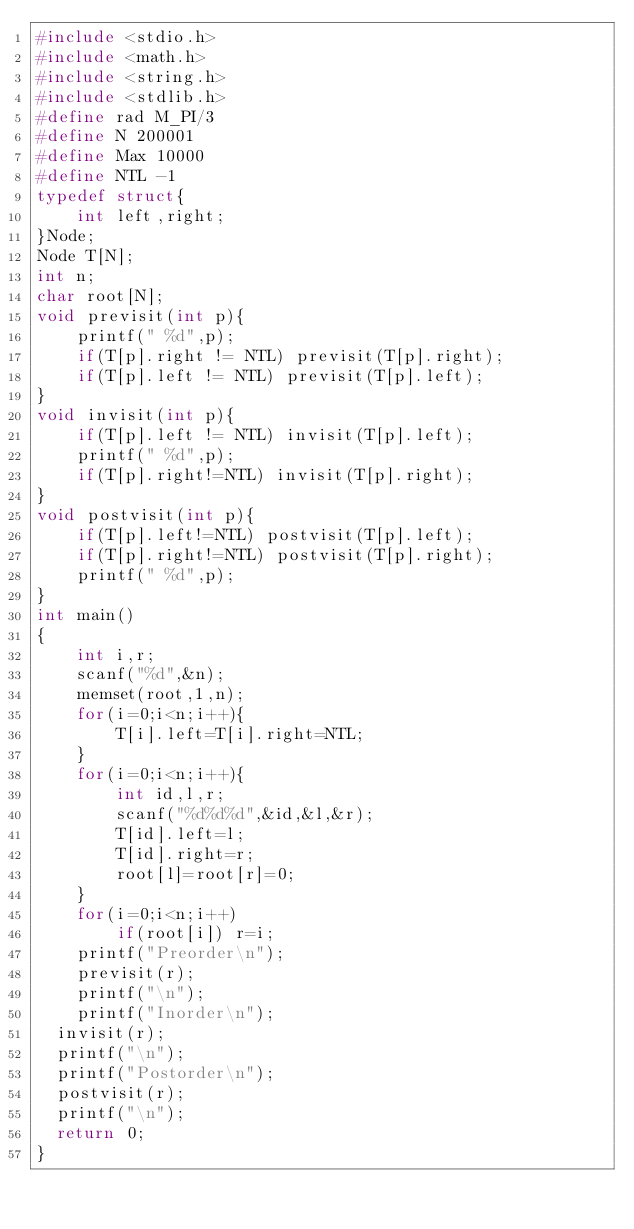Convert code to text. <code><loc_0><loc_0><loc_500><loc_500><_C_>#include <stdio.h>
#include <math.h>
#include <string.h>
#include <stdlib.h>
#define rad M_PI/3
#define N 200001
#define Max 10000
#define NTL -1
typedef struct{
    int left,right;
}Node;
Node T[N];
int n;
char root[N];
void previsit(int p){
    printf(" %d",p);
    if(T[p].right != NTL) previsit(T[p].right);
    if(T[p].left != NTL) previsit(T[p].left);
}
void invisit(int p){
    if(T[p].left != NTL) invisit(T[p].left);
    printf(" %d",p);
    if(T[p].right!=NTL) invisit(T[p].right);
}
void postvisit(int p){
    if(T[p].left!=NTL) postvisit(T[p].left);
    if(T[p].right!=NTL) postvisit(T[p].right);
    printf(" %d",p);
}
int main()
{
    int i,r;
    scanf("%d",&n);
    memset(root,1,n);
    for(i=0;i<n;i++){
        T[i].left=T[i].right=NTL;
    }
    for(i=0;i<n;i++){
        int id,l,r;
        scanf("%d%d%d",&id,&l,&r);
        T[id].left=l;
        T[id].right=r;
        root[l]=root[r]=0;
    }
    for(i=0;i<n;i++)
        if(root[i]) r=i;
    printf("Preorder\n");
    previsit(r);
    printf("\n");
    printf("Inorder\n");
  invisit(r);
  printf("\n");
  printf("Postorder\n");
  postvisit(r);
  printf("\n");
  return 0;
}
</code> 